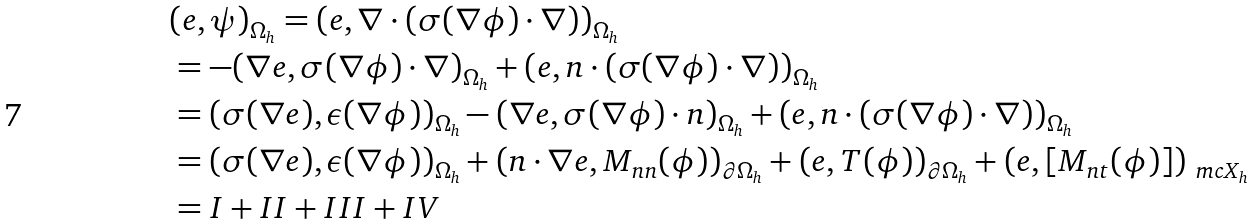<formula> <loc_0><loc_0><loc_500><loc_500>& ( e , \psi ) _ { \Omega _ { h } } = ( e , \nabla \cdot ( \sigma ( \nabla \phi ) \cdot \nabla ) ) _ { \Omega _ { h } } \\ & = - ( \nabla e , \sigma ( \nabla \phi ) \cdot \nabla ) _ { \Omega _ { h } } + ( e , n \cdot ( \sigma ( \nabla \phi ) \cdot \nabla ) ) _ { \Omega _ { h } } \\ & = ( \sigma ( \nabla e ) , \epsilon ( \nabla \phi ) ) _ { \Omega _ { h } } - ( \nabla e , \sigma ( \nabla \phi ) \cdot n ) _ { \Omega _ { h } } + ( e , n \cdot ( \sigma ( \nabla \phi ) \cdot \nabla ) ) _ { \Omega _ { h } } \\ & = ( \sigma ( \nabla e ) , \epsilon ( \nabla \phi ) ) _ { \Omega _ { h } } + ( n \cdot \nabla e , M _ { n n } ( \phi ) ) _ { \partial \Omega _ { h } } + ( e , T ( \phi ) ) _ { \partial \Omega _ { h } } + ( e , [ M _ { n t } ( \phi ) ] ) _ { \ m c X _ { h } } \\ & = I + I I + I I I + I V</formula> 